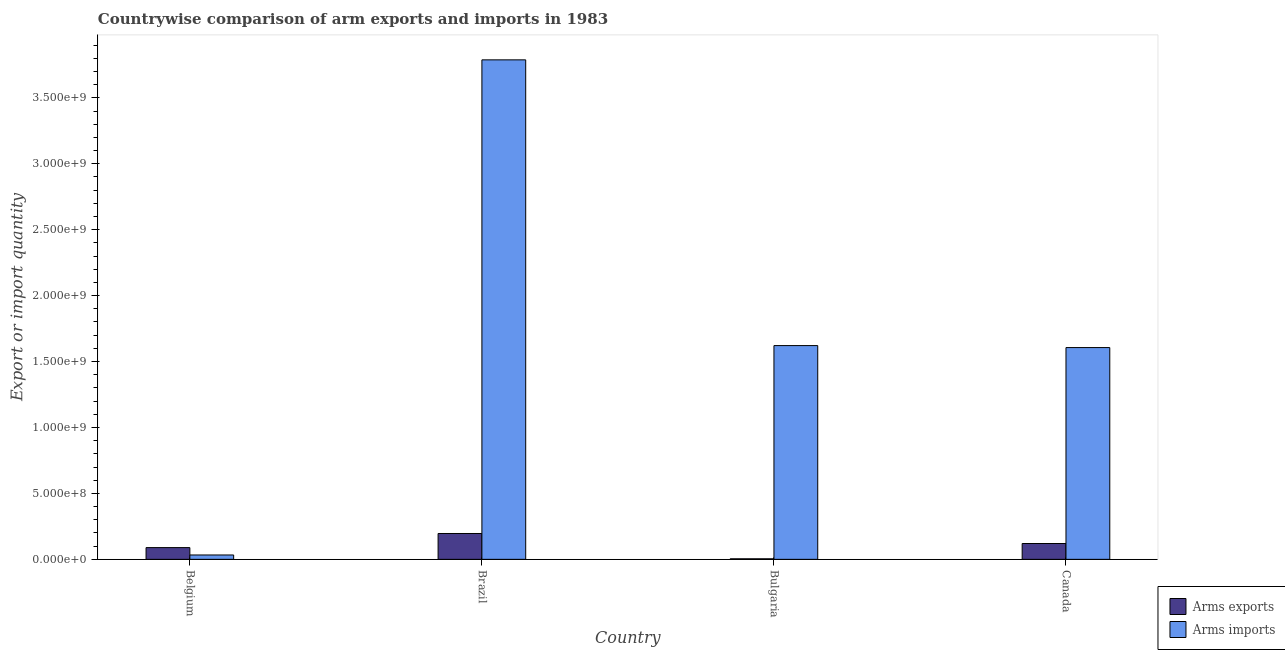How many groups of bars are there?
Give a very brief answer. 4. How many bars are there on the 1st tick from the left?
Your answer should be very brief. 2. How many bars are there on the 3rd tick from the right?
Keep it short and to the point. 2. In how many cases, is the number of bars for a given country not equal to the number of legend labels?
Provide a short and direct response. 0. What is the arms imports in Belgium?
Your answer should be very brief. 3.30e+07. Across all countries, what is the maximum arms exports?
Provide a succinct answer. 1.96e+08. Across all countries, what is the minimum arms exports?
Give a very brief answer. 4.00e+06. In which country was the arms exports maximum?
Provide a short and direct response. Brazil. What is the total arms imports in the graph?
Your answer should be very brief. 7.05e+09. What is the difference between the arms exports in Brazil and that in Bulgaria?
Keep it short and to the point. 1.92e+08. What is the difference between the arms imports in Brazil and the arms exports in Belgium?
Offer a terse response. 3.70e+09. What is the average arms exports per country?
Provide a short and direct response. 1.02e+08. What is the difference between the arms imports and arms exports in Belgium?
Make the answer very short. -5.60e+07. In how many countries, is the arms exports greater than 700000000 ?
Your answer should be very brief. 0. What is the ratio of the arms imports in Brazil to that in Canada?
Offer a very short reply. 2.36. Is the arms imports in Bulgaria less than that in Canada?
Your answer should be very brief. No. Is the difference between the arms exports in Belgium and Canada greater than the difference between the arms imports in Belgium and Canada?
Make the answer very short. Yes. What is the difference between the highest and the second highest arms exports?
Give a very brief answer. 7.60e+07. What is the difference between the highest and the lowest arms imports?
Offer a very short reply. 3.76e+09. Is the sum of the arms exports in Brazil and Canada greater than the maximum arms imports across all countries?
Offer a very short reply. No. What does the 2nd bar from the left in Belgium represents?
Make the answer very short. Arms imports. What does the 2nd bar from the right in Canada represents?
Provide a succinct answer. Arms exports. Are all the bars in the graph horizontal?
Ensure brevity in your answer.  No. Does the graph contain grids?
Offer a terse response. No. Where does the legend appear in the graph?
Provide a short and direct response. Bottom right. How are the legend labels stacked?
Your answer should be compact. Vertical. What is the title of the graph?
Your response must be concise. Countrywise comparison of arm exports and imports in 1983. Does "Investments" appear as one of the legend labels in the graph?
Provide a succinct answer. No. What is the label or title of the X-axis?
Provide a succinct answer. Country. What is the label or title of the Y-axis?
Provide a succinct answer. Export or import quantity. What is the Export or import quantity in Arms exports in Belgium?
Offer a terse response. 8.90e+07. What is the Export or import quantity of Arms imports in Belgium?
Provide a short and direct response. 3.30e+07. What is the Export or import quantity of Arms exports in Brazil?
Your response must be concise. 1.96e+08. What is the Export or import quantity in Arms imports in Brazil?
Give a very brief answer. 3.79e+09. What is the Export or import quantity of Arms imports in Bulgaria?
Your answer should be compact. 1.62e+09. What is the Export or import quantity in Arms exports in Canada?
Provide a short and direct response. 1.20e+08. What is the Export or import quantity of Arms imports in Canada?
Provide a succinct answer. 1.61e+09. Across all countries, what is the maximum Export or import quantity of Arms exports?
Provide a short and direct response. 1.96e+08. Across all countries, what is the maximum Export or import quantity in Arms imports?
Offer a terse response. 3.79e+09. Across all countries, what is the minimum Export or import quantity in Arms imports?
Your answer should be compact. 3.30e+07. What is the total Export or import quantity in Arms exports in the graph?
Provide a short and direct response. 4.09e+08. What is the total Export or import quantity in Arms imports in the graph?
Provide a short and direct response. 7.05e+09. What is the difference between the Export or import quantity in Arms exports in Belgium and that in Brazil?
Provide a short and direct response. -1.07e+08. What is the difference between the Export or import quantity of Arms imports in Belgium and that in Brazil?
Your response must be concise. -3.76e+09. What is the difference between the Export or import quantity in Arms exports in Belgium and that in Bulgaria?
Your answer should be compact. 8.50e+07. What is the difference between the Export or import quantity in Arms imports in Belgium and that in Bulgaria?
Your response must be concise. -1.59e+09. What is the difference between the Export or import quantity of Arms exports in Belgium and that in Canada?
Keep it short and to the point. -3.10e+07. What is the difference between the Export or import quantity in Arms imports in Belgium and that in Canada?
Your answer should be compact. -1.57e+09. What is the difference between the Export or import quantity in Arms exports in Brazil and that in Bulgaria?
Your response must be concise. 1.92e+08. What is the difference between the Export or import quantity in Arms imports in Brazil and that in Bulgaria?
Provide a short and direct response. 2.17e+09. What is the difference between the Export or import quantity of Arms exports in Brazil and that in Canada?
Offer a very short reply. 7.60e+07. What is the difference between the Export or import quantity of Arms imports in Brazil and that in Canada?
Ensure brevity in your answer.  2.18e+09. What is the difference between the Export or import quantity in Arms exports in Bulgaria and that in Canada?
Your answer should be compact. -1.16e+08. What is the difference between the Export or import quantity in Arms imports in Bulgaria and that in Canada?
Give a very brief answer. 1.50e+07. What is the difference between the Export or import quantity of Arms exports in Belgium and the Export or import quantity of Arms imports in Brazil?
Make the answer very short. -3.70e+09. What is the difference between the Export or import quantity in Arms exports in Belgium and the Export or import quantity in Arms imports in Bulgaria?
Provide a short and direct response. -1.53e+09. What is the difference between the Export or import quantity in Arms exports in Belgium and the Export or import quantity in Arms imports in Canada?
Offer a very short reply. -1.52e+09. What is the difference between the Export or import quantity in Arms exports in Brazil and the Export or import quantity in Arms imports in Bulgaria?
Your answer should be very brief. -1.42e+09. What is the difference between the Export or import quantity of Arms exports in Brazil and the Export or import quantity of Arms imports in Canada?
Keep it short and to the point. -1.41e+09. What is the difference between the Export or import quantity of Arms exports in Bulgaria and the Export or import quantity of Arms imports in Canada?
Make the answer very short. -1.60e+09. What is the average Export or import quantity of Arms exports per country?
Provide a succinct answer. 1.02e+08. What is the average Export or import quantity in Arms imports per country?
Your response must be concise. 1.76e+09. What is the difference between the Export or import quantity in Arms exports and Export or import quantity in Arms imports in Belgium?
Your response must be concise. 5.60e+07. What is the difference between the Export or import quantity in Arms exports and Export or import quantity in Arms imports in Brazil?
Offer a very short reply. -3.59e+09. What is the difference between the Export or import quantity of Arms exports and Export or import quantity of Arms imports in Bulgaria?
Keep it short and to the point. -1.62e+09. What is the difference between the Export or import quantity in Arms exports and Export or import quantity in Arms imports in Canada?
Provide a short and direct response. -1.49e+09. What is the ratio of the Export or import quantity in Arms exports in Belgium to that in Brazil?
Provide a short and direct response. 0.45. What is the ratio of the Export or import quantity in Arms imports in Belgium to that in Brazil?
Your answer should be very brief. 0.01. What is the ratio of the Export or import quantity of Arms exports in Belgium to that in Bulgaria?
Offer a very short reply. 22.25. What is the ratio of the Export or import quantity of Arms imports in Belgium to that in Bulgaria?
Your answer should be compact. 0.02. What is the ratio of the Export or import quantity in Arms exports in Belgium to that in Canada?
Provide a succinct answer. 0.74. What is the ratio of the Export or import quantity of Arms imports in Belgium to that in Canada?
Offer a very short reply. 0.02. What is the ratio of the Export or import quantity in Arms exports in Brazil to that in Bulgaria?
Give a very brief answer. 49. What is the ratio of the Export or import quantity in Arms imports in Brazil to that in Bulgaria?
Your answer should be very brief. 2.34. What is the ratio of the Export or import quantity in Arms exports in Brazil to that in Canada?
Keep it short and to the point. 1.63. What is the ratio of the Export or import quantity of Arms imports in Brazil to that in Canada?
Offer a very short reply. 2.36. What is the ratio of the Export or import quantity of Arms exports in Bulgaria to that in Canada?
Offer a very short reply. 0.03. What is the ratio of the Export or import quantity of Arms imports in Bulgaria to that in Canada?
Your answer should be compact. 1.01. What is the difference between the highest and the second highest Export or import quantity of Arms exports?
Offer a very short reply. 7.60e+07. What is the difference between the highest and the second highest Export or import quantity of Arms imports?
Your answer should be compact. 2.17e+09. What is the difference between the highest and the lowest Export or import quantity in Arms exports?
Your response must be concise. 1.92e+08. What is the difference between the highest and the lowest Export or import quantity of Arms imports?
Provide a succinct answer. 3.76e+09. 